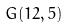<formula> <loc_0><loc_0><loc_500><loc_500>G ( 1 2 , 5 )</formula> 